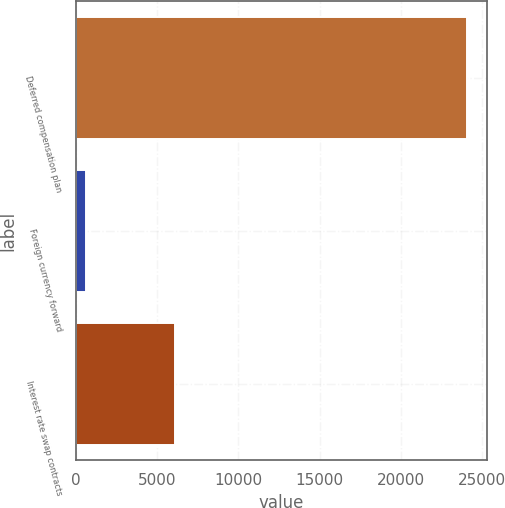Convert chart. <chart><loc_0><loc_0><loc_500><loc_500><bar_chart><fcel>Deferred compensation plan<fcel>Foreign currency forward<fcel>Interest rate swap contracts<nl><fcel>24113<fcel>618<fcel>6067<nl></chart> 